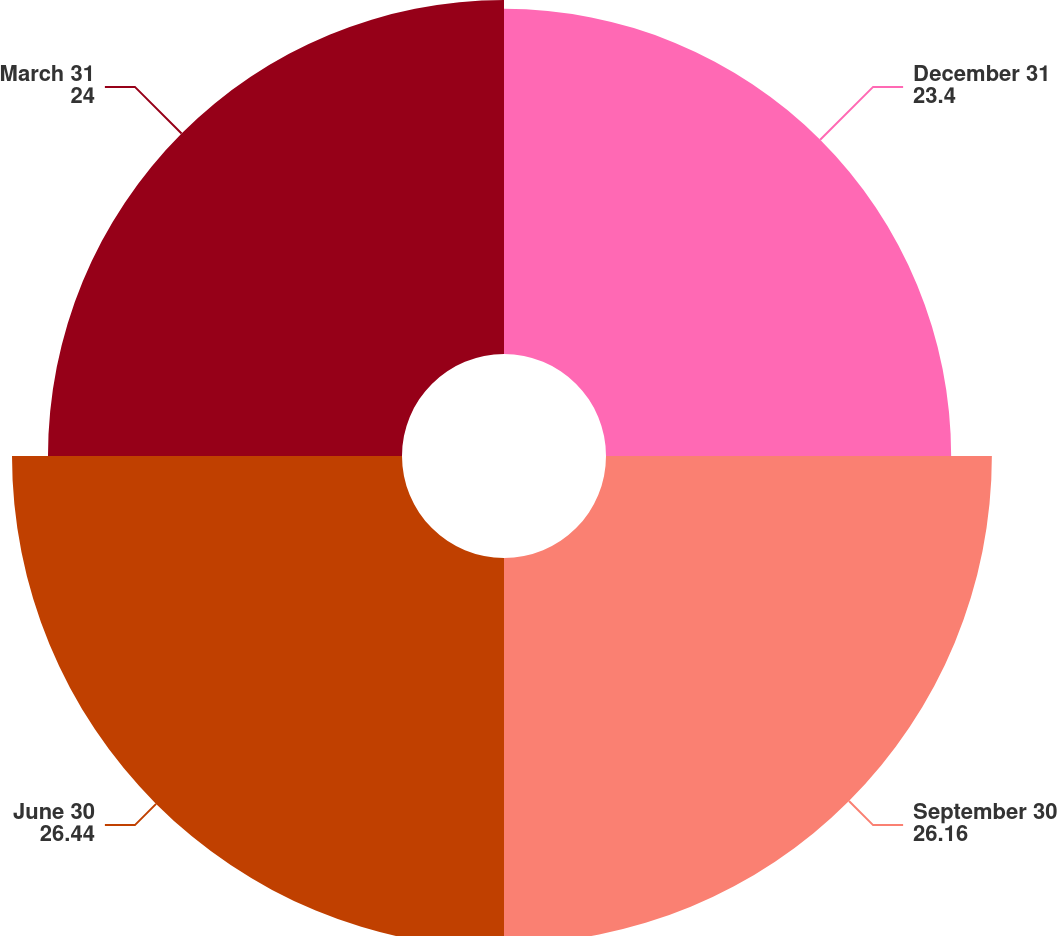<chart> <loc_0><loc_0><loc_500><loc_500><pie_chart><fcel>December 31<fcel>September 30<fcel>June 30<fcel>March 31<nl><fcel>23.4%<fcel>26.16%<fcel>26.44%<fcel>24.0%<nl></chart> 